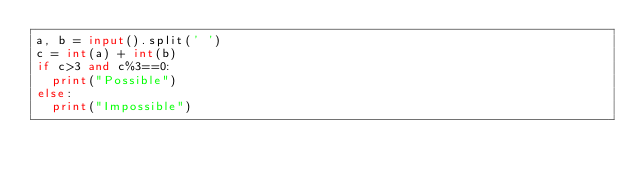<code> <loc_0><loc_0><loc_500><loc_500><_Python_>a, b = input().split(' ')
c = int(a) + int(b)
if c>3 and c%3==0:
  print("Possible")
else:
  print("Impossible")</code> 